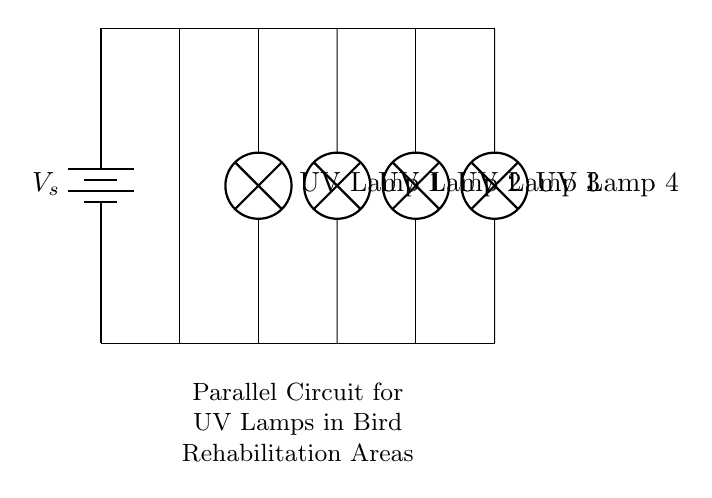What type of circuit is shown? The circuit diagram depicts a parallel circuit, where multiple components (UV lamps) are connected across the same voltage source. In a parallel configuration, each lamp operates independently and receives the same voltage, as seen by the top connections all leading to the same power source.
Answer: Parallel circuit How many UV lamps are present? By examining the circuit diagram, we can count the number of UV lamps depicted. There are four distinct lamps represented, labeled as UV Lamp 1, UV Lamp 2, UV Lamp 3, and UV Lamp 4. This straightforward counting leads us to the answer.
Answer: Four What connects all the lamps together? The lamps are connected by wire segments that allow current to flow between them. Each lamp has its own pathway to the voltage source, and the horizontal lines above the lamps indicate that they are all connected in parallel, linking them to the same battery.
Answer: Wires What is the main voltage supply labeled as? The main voltage supply is identified in the circuit as "V_s" connected to the upper part of the diagram, indicating it is the source of electrical energy for the lamps. This labeling is standard practice in circuit diagrams to denote voltage sources.
Answer: V_s Are the UV lamps dependent on each other? In a parallel circuit, each lamp functions independently because they are connected directly to the same voltage source. So, if one lamp fails, the others will continue to operate normally without affecting each other's performance. This independence is a key feature of parallel circuits.
Answer: No What would happen if one UV lamp burns out? If one UV lamp fails in a parallel circuit, the other lamps will continue to operate unaffected. This is because the remaining lamps each have their own path to the voltage, meaning the current can still flow through the other paths. Therefore, the overall operation of the circuit remains stable.
Answer: Others stay lit 